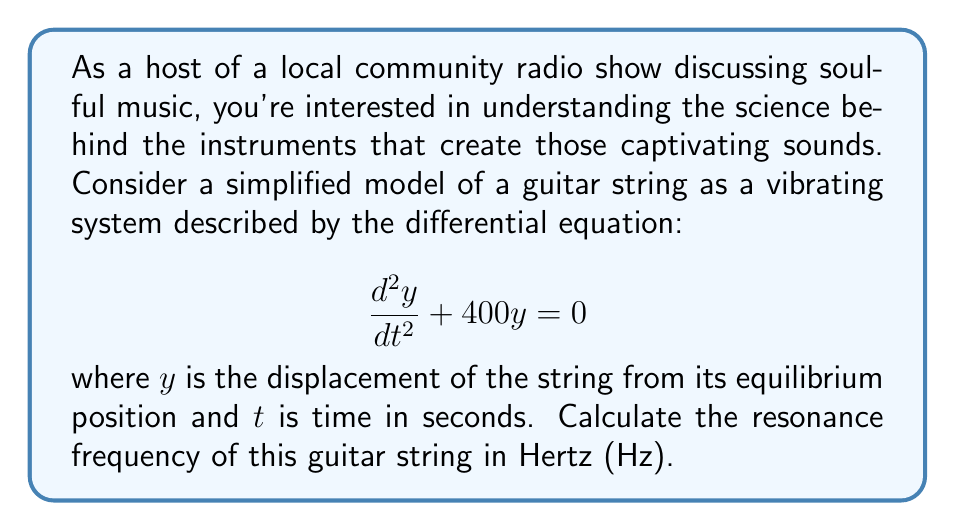Teach me how to tackle this problem. To solve this problem, we'll follow these steps:

1) The given differential equation is in the form of a simple harmonic oscillator:

   $$\frac{d^2y}{dt^2} + \omega^2y = 0$$

   where $\omega$ is the angular frequency in radians per second.

2) Comparing our equation to this standard form, we can see that:

   $$\omega^2 = 400$$

3) Solve for $\omega$:

   $$\omega = \sqrt{400} = 20 \text{ rad/s}$$

4) The relationship between angular frequency $\omega$ and frequency $f$ in Hz is:

   $$\omega = 2\pi f$$

5) Substitute our value for $\omega$ and solve for $f$:

   $$20 = 2\pi f$$
   $$f = \frac{20}{2\pi} \approx 3.18 \text{ Hz}$$

6) Round to two decimal places for our final answer.
Answer: 3.18 Hz 